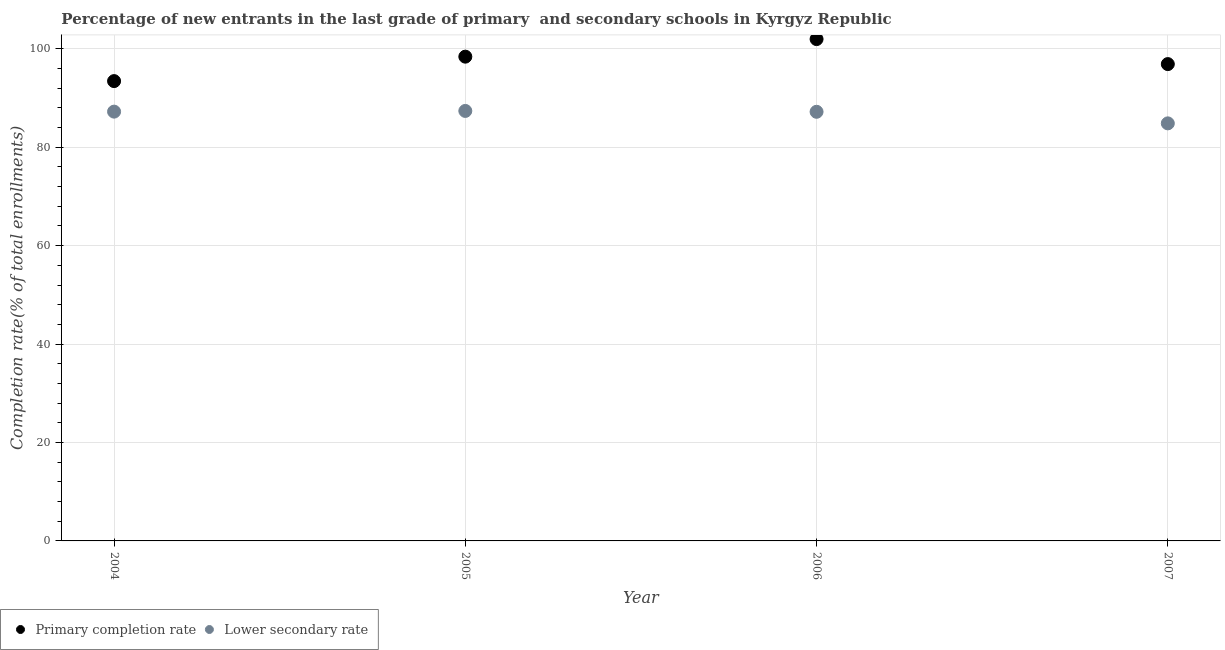What is the completion rate in secondary schools in 2005?
Give a very brief answer. 87.38. Across all years, what is the maximum completion rate in primary schools?
Your answer should be very brief. 101.98. Across all years, what is the minimum completion rate in primary schools?
Give a very brief answer. 93.44. What is the total completion rate in secondary schools in the graph?
Ensure brevity in your answer.  346.67. What is the difference between the completion rate in secondary schools in 2004 and that in 2006?
Your response must be concise. 0.03. What is the difference between the completion rate in secondary schools in 2007 and the completion rate in primary schools in 2004?
Give a very brief answer. -8.59. What is the average completion rate in secondary schools per year?
Ensure brevity in your answer.  86.67. In the year 2007, what is the difference between the completion rate in primary schools and completion rate in secondary schools?
Provide a short and direct response. 12.04. What is the ratio of the completion rate in secondary schools in 2004 to that in 2006?
Your answer should be compact. 1. Is the completion rate in secondary schools in 2004 less than that in 2006?
Provide a short and direct response. No. Is the difference between the completion rate in primary schools in 2006 and 2007 greater than the difference between the completion rate in secondary schools in 2006 and 2007?
Give a very brief answer. Yes. What is the difference between the highest and the second highest completion rate in primary schools?
Provide a short and direct response. 3.57. What is the difference between the highest and the lowest completion rate in secondary schools?
Keep it short and to the point. 2.53. In how many years, is the completion rate in secondary schools greater than the average completion rate in secondary schools taken over all years?
Ensure brevity in your answer.  3. Is the sum of the completion rate in secondary schools in 2006 and 2007 greater than the maximum completion rate in primary schools across all years?
Give a very brief answer. Yes. Is the completion rate in secondary schools strictly greater than the completion rate in primary schools over the years?
Offer a terse response. No. Is the completion rate in secondary schools strictly less than the completion rate in primary schools over the years?
Offer a terse response. Yes. How many dotlines are there?
Offer a terse response. 2. Are the values on the major ticks of Y-axis written in scientific E-notation?
Keep it short and to the point. No. Does the graph contain any zero values?
Offer a very short reply. No. Does the graph contain grids?
Your answer should be very brief. Yes. How are the legend labels stacked?
Provide a succinct answer. Horizontal. What is the title of the graph?
Provide a succinct answer. Percentage of new entrants in the last grade of primary  and secondary schools in Kyrgyz Republic. What is the label or title of the Y-axis?
Offer a very short reply. Completion rate(% of total enrollments). What is the Completion rate(% of total enrollments) in Primary completion rate in 2004?
Make the answer very short. 93.44. What is the Completion rate(% of total enrollments) of Lower secondary rate in 2004?
Provide a short and direct response. 87.24. What is the Completion rate(% of total enrollments) in Primary completion rate in 2005?
Your response must be concise. 98.41. What is the Completion rate(% of total enrollments) in Lower secondary rate in 2005?
Keep it short and to the point. 87.38. What is the Completion rate(% of total enrollments) in Primary completion rate in 2006?
Your answer should be compact. 101.98. What is the Completion rate(% of total enrollments) in Lower secondary rate in 2006?
Offer a terse response. 87.2. What is the Completion rate(% of total enrollments) of Primary completion rate in 2007?
Offer a very short reply. 96.9. What is the Completion rate(% of total enrollments) in Lower secondary rate in 2007?
Give a very brief answer. 84.85. Across all years, what is the maximum Completion rate(% of total enrollments) in Primary completion rate?
Your response must be concise. 101.98. Across all years, what is the maximum Completion rate(% of total enrollments) in Lower secondary rate?
Give a very brief answer. 87.38. Across all years, what is the minimum Completion rate(% of total enrollments) in Primary completion rate?
Give a very brief answer. 93.44. Across all years, what is the minimum Completion rate(% of total enrollments) of Lower secondary rate?
Your response must be concise. 84.85. What is the total Completion rate(% of total enrollments) in Primary completion rate in the graph?
Provide a short and direct response. 390.72. What is the total Completion rate(% of total enrollments) of Lower secondary rate in the graph?
Offer a terse response. 346.67. What is the difference between the Completion rate(% of total enrollments) in Primary completion rate in 2004 and that in 2005?
Provide a short and direct response. -4.97. What is the difference between the Completion rate(% of total enrollments) in Lower secondary rate in 2004 and that in 2005?
Provide a short and direct response. -0.14. What is the difference between the Completion rate(% of total enrollments) of Primary completion rate in 2004 and that in 2006?
Provide a short and direct response. -8.54. What is the difference between the Completion rate(% of total enrollments) of Lower secondary rate in 2004 and that in 2006?
Make the answer very short. 0.03. What is the difference between the Completion rate(% of total enrollments) in Primary completion rate in 2004 and that in 2007?
Offer a terse response. -3.46. What is the difference between the Completion rate(% of total enrollments) in Lower secondary rate in 2004 and that in 2007?
Your answer should be very brief. 2.38. What is the difference between the Completion rate(% of total enrollments) in Primary completion rate in 2005 and that in 2006?
Keep it short and to the point. -3.57. What is the difference between the Completion rate(% of total enrollments) in Lower secondary rate in 2005 and that in 2006?
Provide a succinct answer. 0.17. What is the difference between the Completion rate(% of total enrollments) of Primary completion rate in 2005 and that in 2007?
Offer a very short reply. 1.51. What is the difference between the Completion rate(% of total enrollments) in Lower secondary rate in 2005 and that in 2007?
Your answer should be very brief. 2.53. What is the difference between the Completion rate(% of total enrollments) of Primary completion rate in 2006 and that in 2007?
Your answer should be very brief. 5.08. What is the difference between the Completion rate(% of total enrollments) in Lower secondary rate in 2006 and that in 2007?
Offer a terse response. 2.35. What is the difference between the Completion rate(% of total enrollments) in Primary completion rate in 2004 and the Completion rate(% of total enrollments) in Lower secondary rate in 2005?
Ensure brevity in your answer.  6.06. What is the difference between the Completion rate(% of total enrollments) of Primary completion rate in 2004 and the Completion rate(% of total enrollments) of Lower secondary rate in 2006?
Offer a very short reply. 6.24. What is the difference between the Completion rate(% of total enrollments) of Primary completion rate in 2004 and the Completion rate(% of total enrollments) of Lower secondary rate in 2007?
Provide a succinct answer. 8.59. What is the difference between the Completion rate(% of total enrollments) of Primary completion rate in 2005 and the Completion rate(% of total enrollments) of Lower secondary rate in 2006?
Offer a very short reply. 11.2. What is the difference between the Completion rate(% of total enrollments) in Primary completion rate in 2005 and the Completion rate(% of total enrollments) in Lower secondary rate in 2007?
Give a very brief answer. 13.56. What is the difference between the Completion rate(% of total enrollments) in Primary completion rate in 2006 and the Completion rate(% of total enrollments) in Lower secondary rate in 2007?
Offer a terse response. 17.13. What is the average Completion rate(% of total enrollments) in Primary completion rate per year?
Your answer should be very brief. 97.68. What is the average Completion rate(% of total enrollments) in Lower secondary rate per year?
Ensure brevity in your answer.  86.67. In the year 2004, what is the difference between the Completion rate(% of total enrollments) of Primary completion rate and Completion rate(% of total enrollments) of Lower secondary rate?
Provide a short and direct response. 6.2. In the year 2005, what is the difference between the Completion rate(% of total enrollments) in Primary completion rate and Completion rate(% of total enrollments) in Lower secondary rate?
Make the answer very short. 11.03. In the year 2006, what is the difference between the Completion rate(% of total enrollments) of Primary completion rate and Completion rate(% of total enrollments) of Lower secondary rate?
Make the answer very short. 14.77. In the year 2007, what is the difference between the Completion rate(% of total enrollments) in Primary completion rate and Completion rate(% of total enrollments) in Lower secondary rate?
Provide a short and direct response. 12.04. What is the ratio of the Completion rate(% of total enrollments) in Primary completion rate in 2004 to that in 2005?
Your answer should be compact. 0.95. What is the ratio of the Completion rate(% of total enrollments) of Lower secondary rate in 2004 to that in 2005?
Keep it short and to the point. 1. What is the ratio of the Completion rate(% of total enrollments) in Primary completion rate in 2004 to that in 2006?
Ensure brevity in your answer.  0.92. What is the ratio of the Completion rate(% of total enrollments) in Lower secondary rate in 2004 to that in 2006?
Your answer should be compact. 1. What is the ratio of the Completion rate(% of total enrollments) in Primary completion rate in 2004 to that in 2007?
Your answer should be compact. 0.96. What is the ratio of the Completion rate(% of total enrollments) of Lower secondary rate in 2004 to that in 2007?
Your answer should be very brief. 1.03. What is the ratio of the Completion rate(% of total enrollments) in Lower secondary rate in 2005 to that in 2006?
Your answer should be very brief. 1. What is the ratio of the Completion rate(% of total enrollments) in Primary completion rate in 2005 to that in 2007?
Your answer should be compact. 1.02. What is the ratio of the Completion rate(% of total enrollments) in Lower secondary rate in 2005 to that in 2007?
Make the answer very short. 1.03. What is the ratio of the Completion rate(% of total enrollments) in Primary completion rate in 2006 to that in 2007?
Provide a short and direct response. 1.05. What is the ratio of the Completion rate(% of total enrollments) of Lower secondary rate in 2006 to that in 2007?
Give a very brief answer. 1.03. What is the difference between the highest and the second highest Completion rate(% of total enrollments) of Primary completion rate?
Make the answer very short. 3.57. What is the difference between the highest and the second highest Completion rate(% of total enrollments) of Lower secondary rate?
Your answer should be compact. 0.14. What is the difference between the highest and the lowest Completion rate(% of total enrollments) in Primary completion rate?
Ensure brevity in your answer.  8.54. What is the difference between the highest and the lowest Completion rate(% of total enrollments) in Lower secondary rate?
Ensure brevity in your answer.  2.53. 